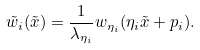<formula> <loc_0><loc_0><loc_500><loc_500>\tilde { w } _ { i } ( \tilde { x } ) = \frac { 1 } { \lambda _ { \eta _ { i } } } w _ { \eta _ { i } } ( \eta _ { i } \tilde { x } + p _ { i } ) .</formula> 